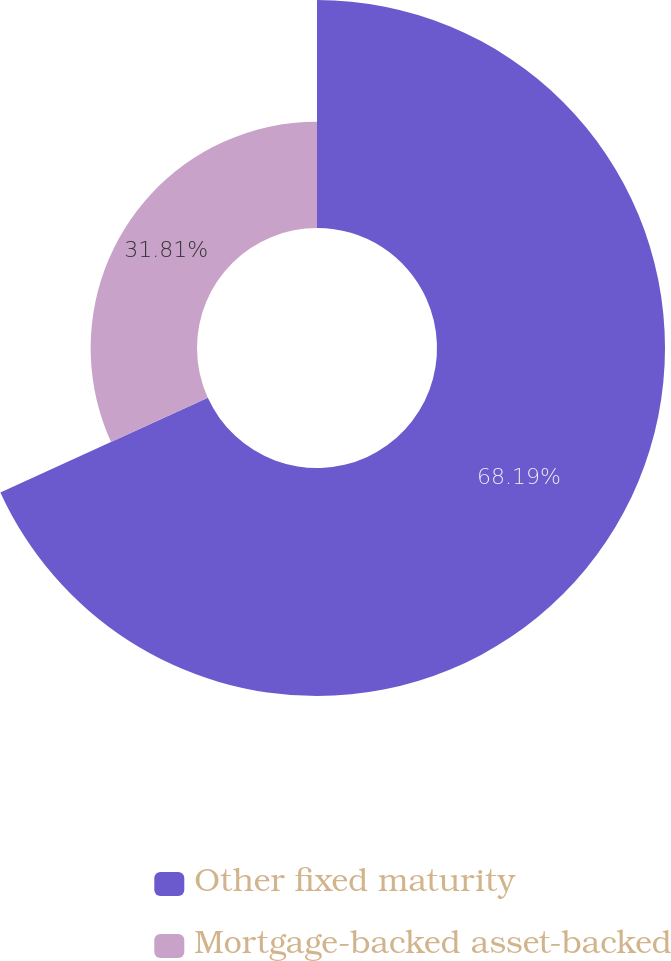Convert chart. <chart><loc_0><loc_0><loc_500><loc_500><pie_chart><fcel>Other fixed maturity<fcel>Mortgage-backed asset-backed<nl><fcel>68.19%<fcel>31.81%<nl></chart> 